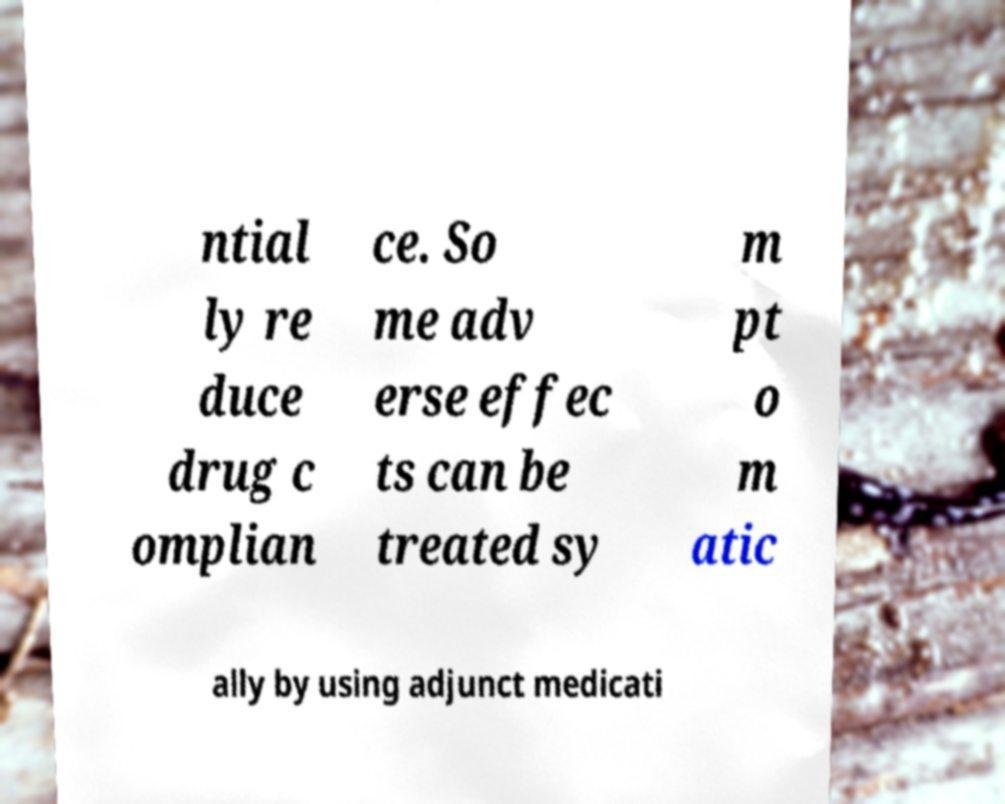Could you extract and type out the text from this image? ntial ly re duce drug c omplian ce. So me adv erse effec ts can be treated sy m pt o m atic ally by using adjunct medicati 